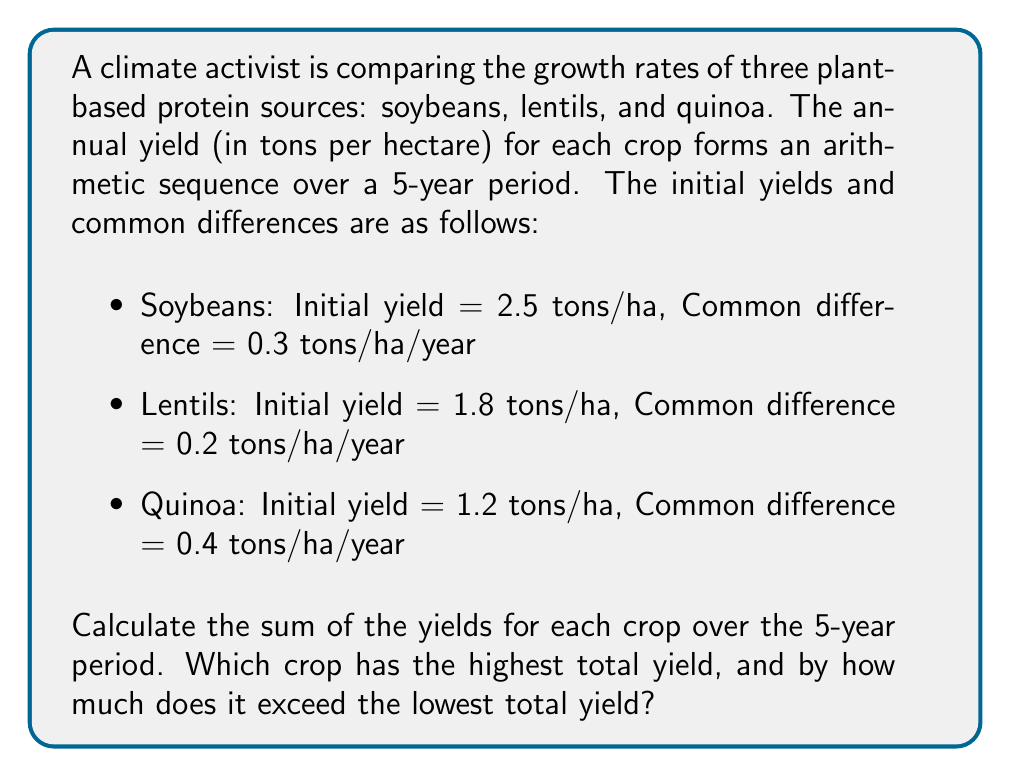Can you answer this question? Let's approach this problem step-by-step using the arithmetic sequence formula for the sum of n terms:

$$ S_n = \frac{n}{2}(a_1 + a_n) $$

Where $S_n$ is the sum of n terms, $n$ is the number of terms, $a_1$ is the first term, and $a_n$ is the last term.

For an arithmetic sequence, the nth term is given by:

$$ a_n = a_1 + (n-1)d $$

Where $d$ is the common difference.

1. For Soybeans:
   $a_1 = 2.5$, $d = 0.3$, $n = 5$
   $a_5 = 2.5 + (5-1)(0.3) = 3.7$
   $S_5 = \frac{5}{2}(2.5 + 3.7) = 15.5$ tons/ha

2. For Lentils:
   $a_1 = 1.8$, $d = 0.2$, $n = 5$
   $a_5 = 1.8 + (5-1)(0.2) = 2.6$
   $S_5 = \frac{5}{2}(1.8 + 2.6) = 11$ tons/ha

3. For Quinoa:
   $a_1 = 1.2$, $d = 0.4$, $n = 5$
   $a_5 = 1.2 + (5-1)(0.4) = 2.8$
   $S_5 = \frac{5}{2}(1.2 + 2.8) = 10$ tons/ha

Soybeans have the highest total yield at 15.5 tons/ha, while Quinoa has the lowest at 10 tons/ha.

The difference between the highest and lowest yields is:
15.5 - 10 = 5.5 tons/ha
Answer: Soybeans have the highest total yield over the 5-year period at 15.5 tons/ha, exceeding the lowest total yield (Quinoa at 10 tons/ha) by 5.5 tons/ha. 